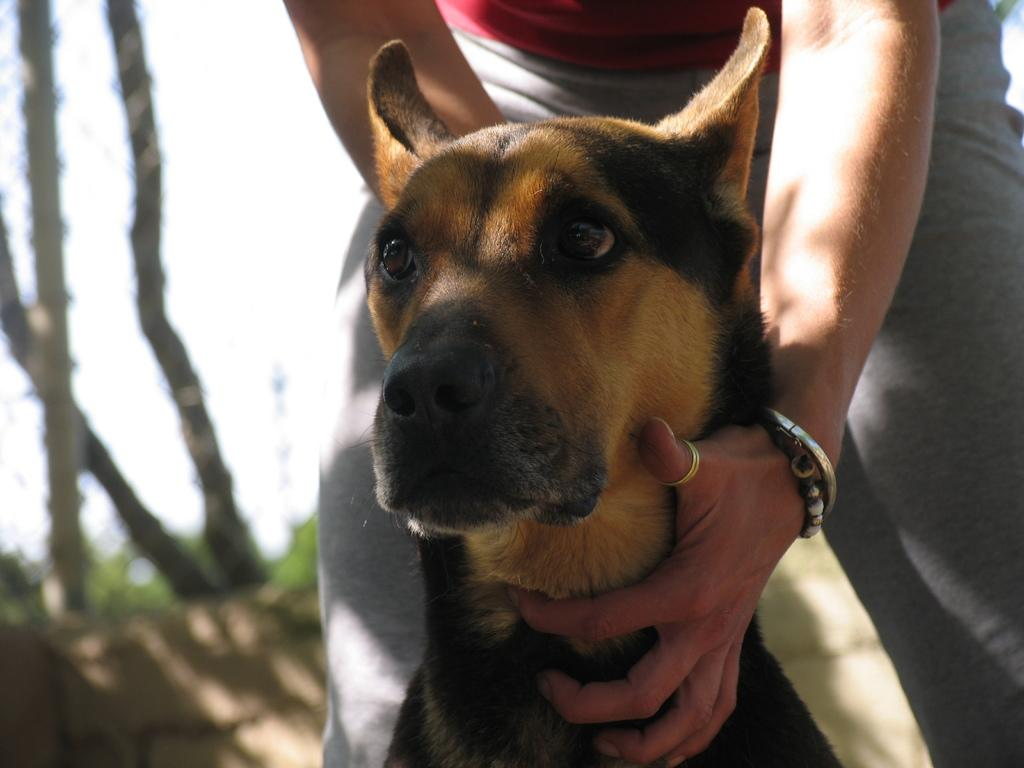What is the main subject of the image? There is a person in the image. What is the person wearing? The person is wearing bangles. What is the person holding in the image? The person is holding a dog. What can be seen in the background of the image? There are tree trunks in the background of the image. How would you describe the background of the image? The background is blurred. What type of circle is visible on the book the person is reading in the image? There is no book or circle present in the image. How many sisters does the person have in the image? There is no mention of sisters or any other family members in the image. 